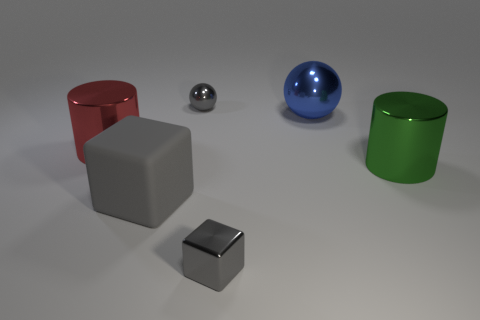The metal object that is the same color as the small cube is what shape?
Your answer should be very brief. Sphere. What number of things are either objects that are on the right side of the big sphere or gray blocks?
Offer a very short reply. 3. There is a red cylinder that is made of the same material as the small gray cube; what is its size?
Provide a short and direct response. Large. Is the size of the rubber cube the same as the cylinder right of the red object?
Provide a short and direct response. Yes. There is a object that is in front of the red metallic cylinder and behind the gray rubber object; what color is it?
Keep it short and to the point. Green. How many things are either tiny objects that are in front of the red shiny thing or small shiny things that are in front of the green object?
Your answer should be compact. 1. The large cylinder on the right side of the sphere to the left of the metallic object that is in front of the green shiny object is what color?
Offer a terse response. Green. Are there any large blue things that have the same shape as the gray matte object?
Ensure brevity in your answer.  No. What number of tiny metal things are there?
Your answer should be compact. 2. What shape is the large blue thing?
Provide a short and direct response. Sphere. 